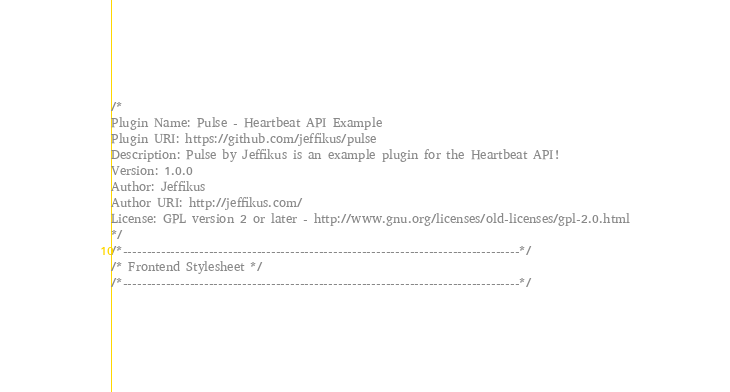Convert code to text. <code><loc_0><loc_0><loc_500><loc_500><_CSS_>/*
Plugin Name: Pulse - Heartbeat API Example
Plugin URI: https://github.com/jeffikus/pulse
Description: Pulse by Jeffikus is an example plugin for the Heartbeat API!
Version: 1.0.0
Author: Jeffikus
Author URI: http://jeffikus.com/
License: GPL version 2 or later - http://www.gnu.org/licenses/old-licenses/gpl-2.0.html
*/
/*-----------------------------------------------------------------------------------*/
/* Frontend Stylesheet */
/*-----------------------------------------------------------------------------------*/</code> 